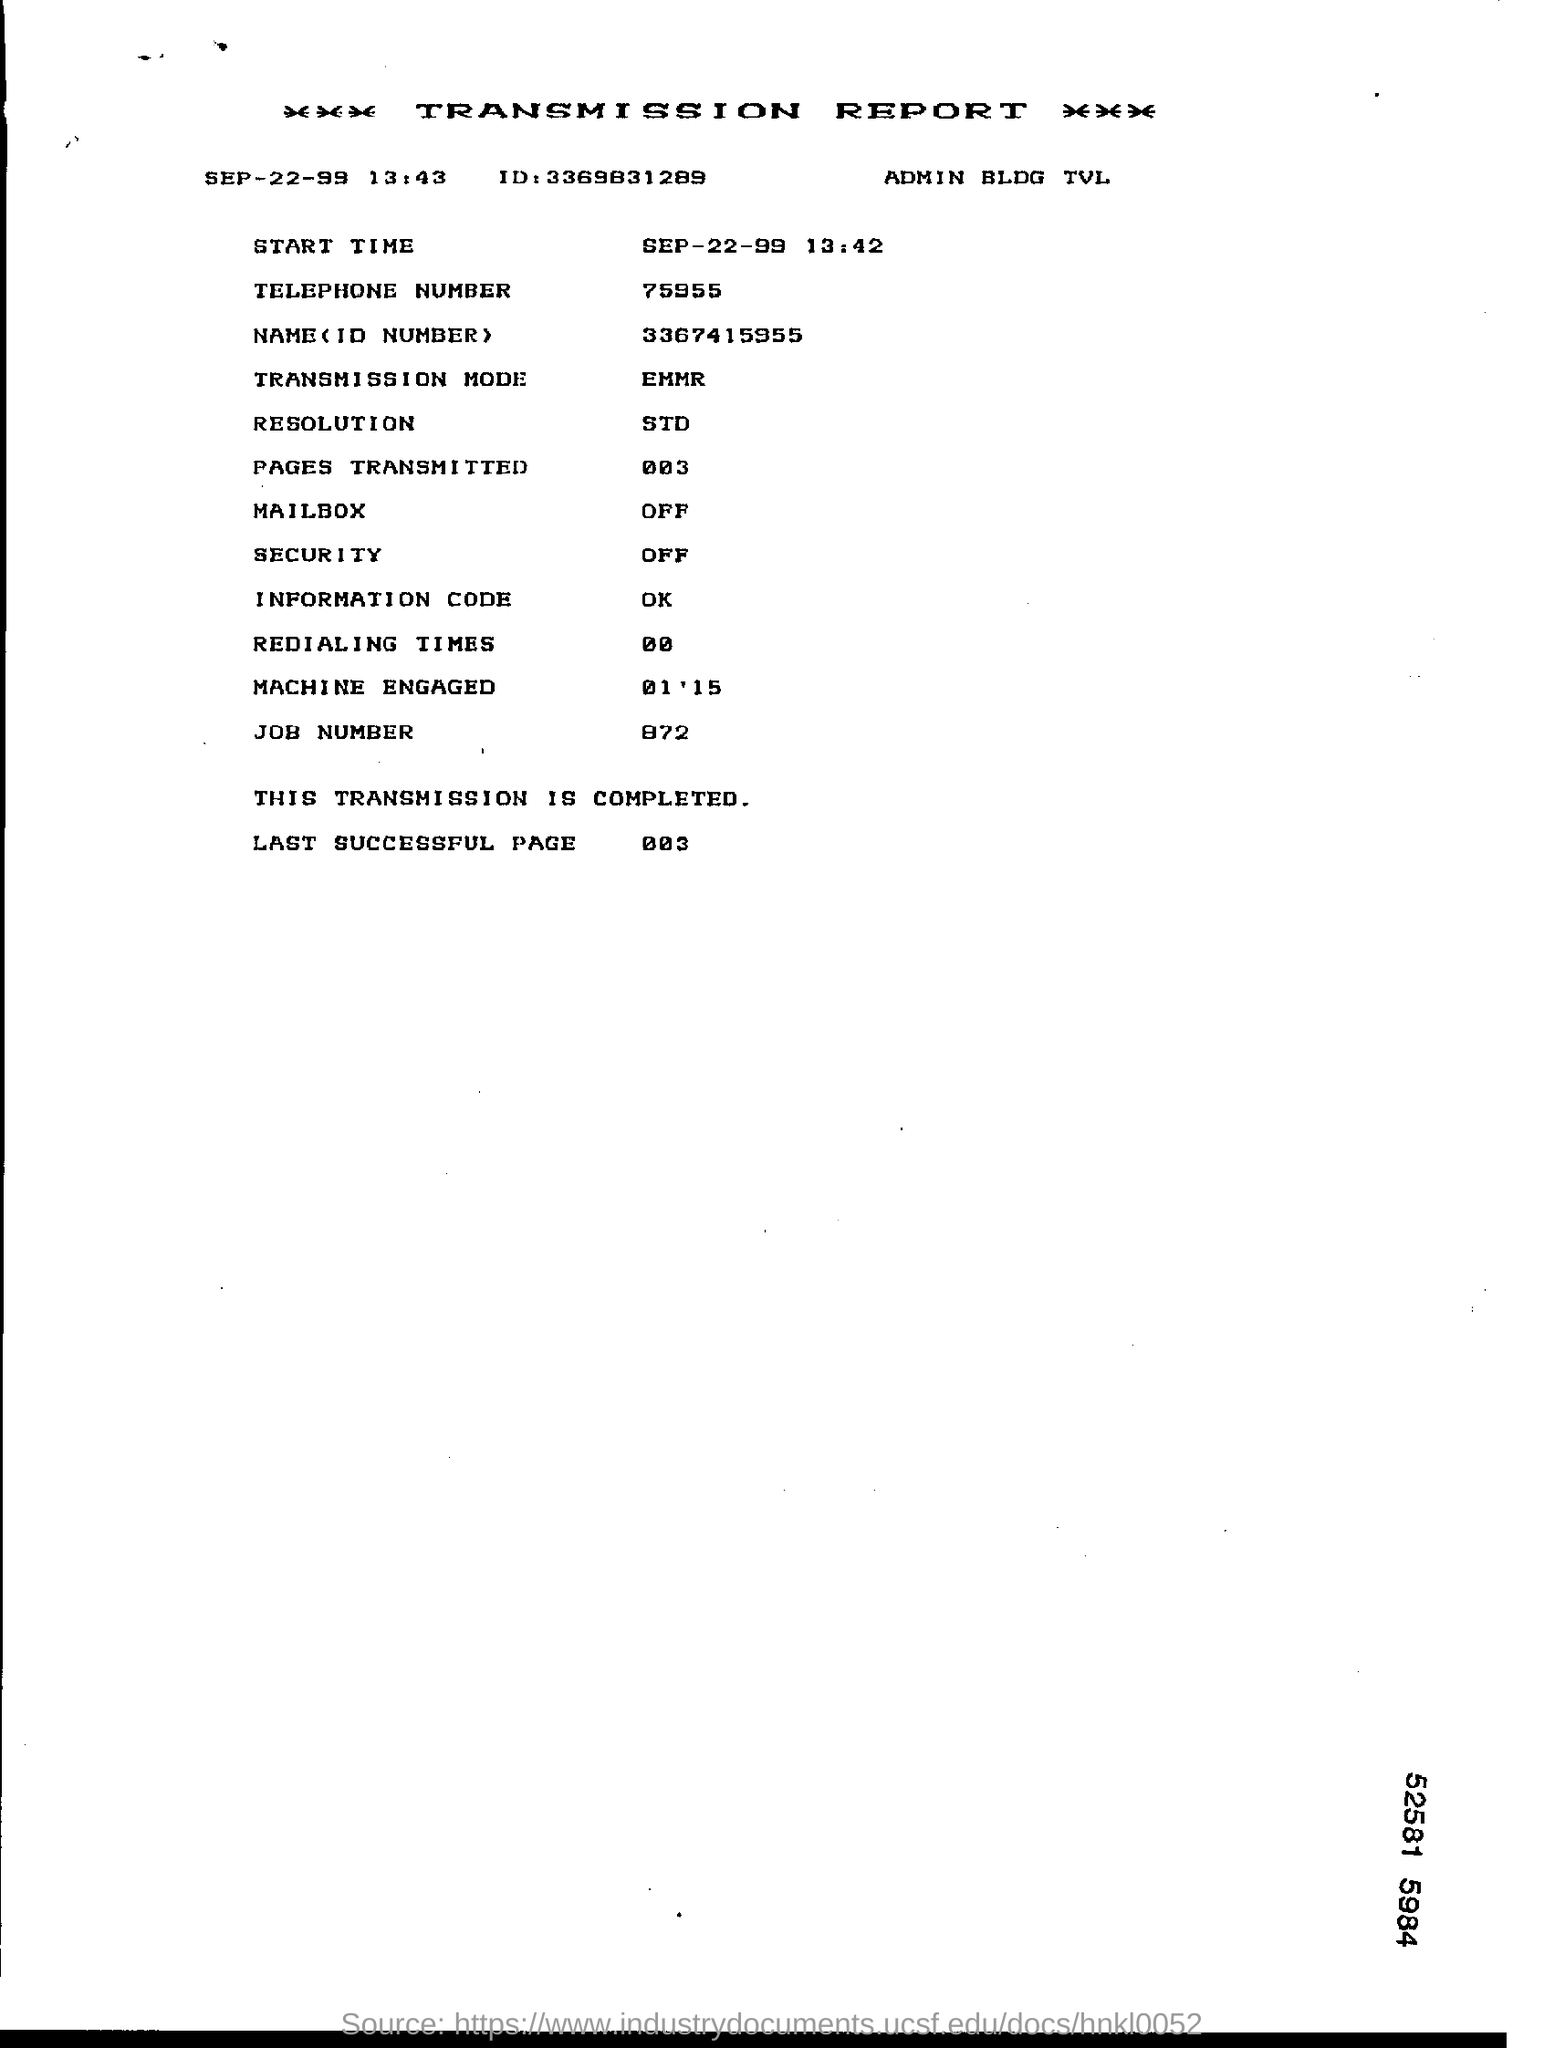What is the telephone number in the report?
Offer a very short reply. 75955. What is the job number?
Your answer should be compact. 872. 